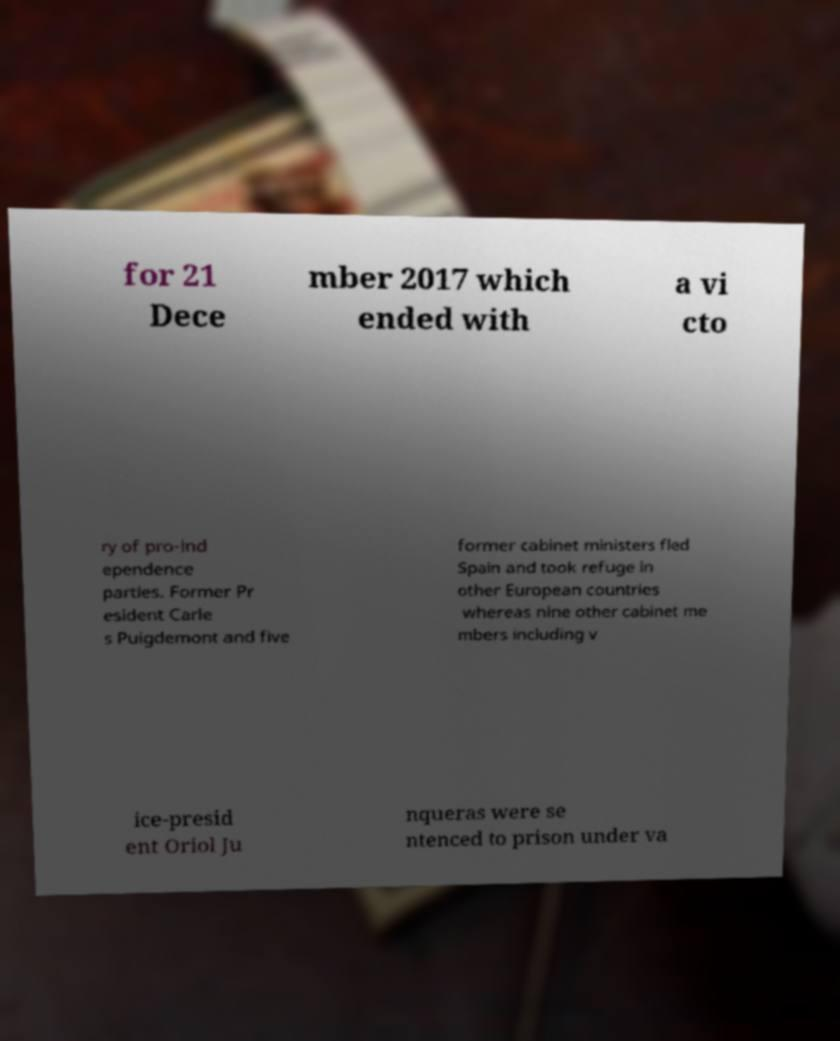Can you read and provide the text displayed in the image?This photo seems to have some interesting text. Can you extract and type it out for me? for 21 Dece mber 2017 which ended with a vi cto ry of pro-ind ependence parties. Former Pr esident Carle s Puigdemont and five former cabinet ministers fled Spain and took refuge in other European countries whereas nine other cabinet me mbers including v ice-presid ent Oriol Ju nqueras were se ntenced to prison under va 